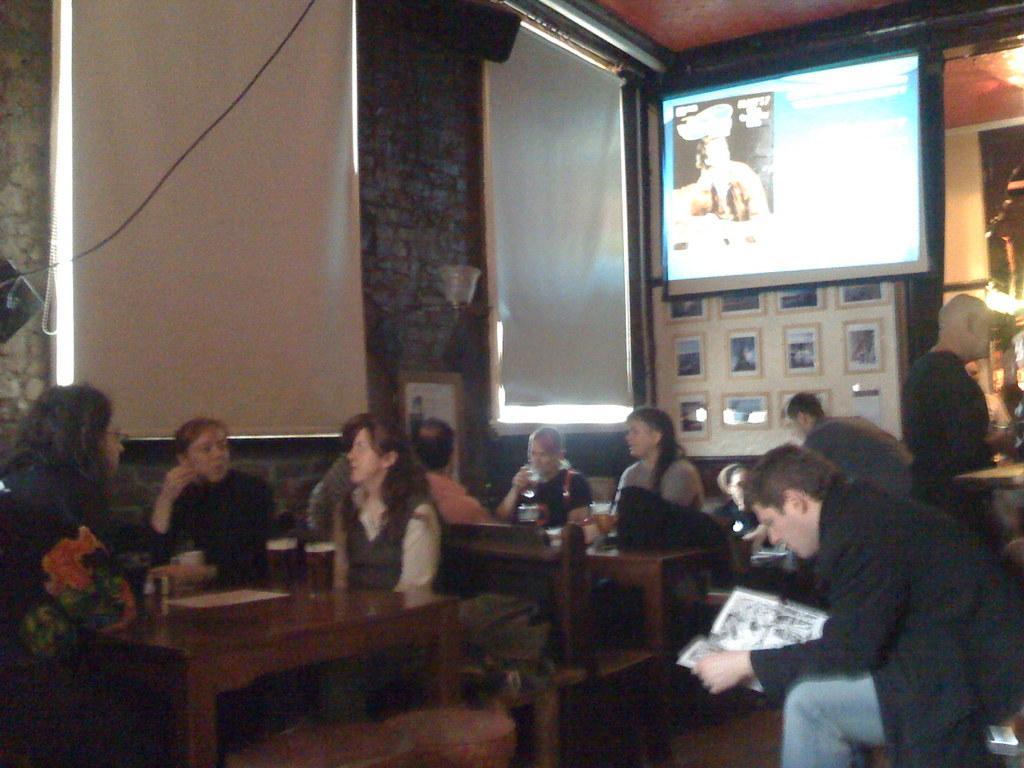Could you give a brief overview of what you see in this image? This image is clicked in a restaurant. There are many people in this image. To the right there is a screen on the wall. To the left, there is a window covered with window blind. In the front there is a table on which two beer glasses are kept. To the right, the man wearing black color jacket. 